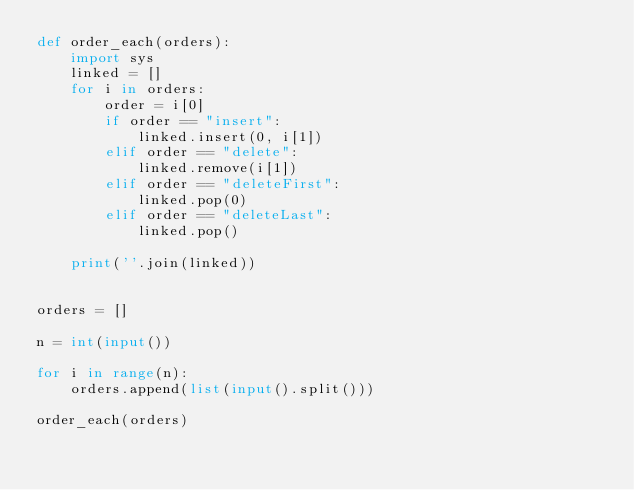<code> <loc_0><loc_0><loc_500><loc_500><_Python_>def order_each(orders):
    import sys
    linked = []
    for i in orders:
        order = i[0]
        if order == "insert":
            linked.insert(0, i[1])
        elif order == "delete":
            linked.remove(i[1])
        elif order == "deleteFirst":
            linked.pop(0)
        elif order == "deleteLast":
            linked.pop()

    print(''.join(linked))


orders = []

n = int(input())

for i in range(n):
    orders.append(list(input().split()))

order_each(orders)</code> 